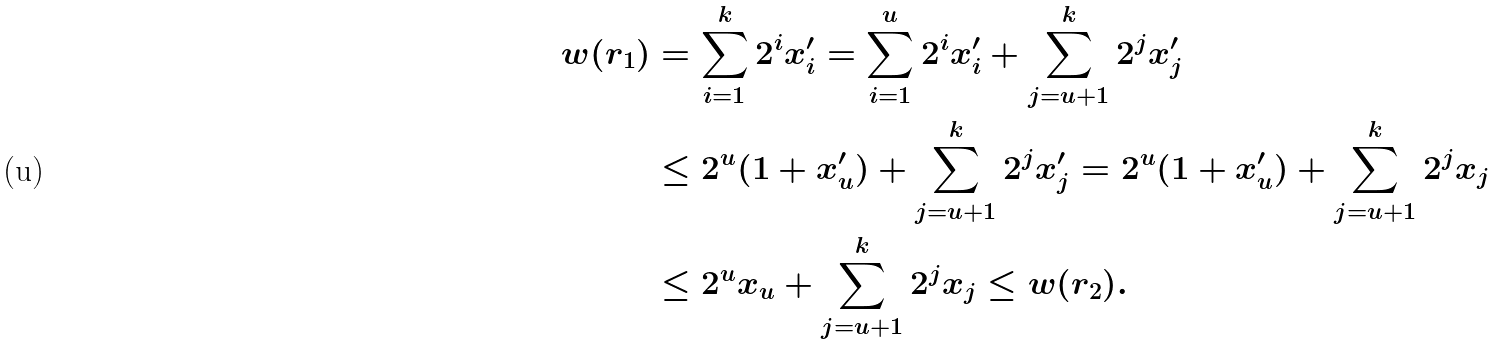Convert formula to latex. <formula><loc_0><loc_0><loc_500><loc_500>w ( r _ { 1 } ) & = \sum _ { i = 1 } ^ { k } 2 ^ { i } x _ { i } ^ { \prime } = \sum _ { i = 1 } ^ { u } 2 ^ { i } x _ { i } ^ { \prime } + \sum _ { j = u + 1 } ^ { k } 2 ^ { j } x _ { j } ^ { \prime } \\ & \leq 2 ^ { u } ( 1 + x _ { u } ^ { \prime } ) + \sum _ { j = u + 1 } ^ { k } 2 ^ { j } x _ { j } ^ { \prime } = 2 ^ { u } ( 1 + x _ { u } ^ { \prime } ) + \sum _ { j = u + 1 } ^ { k } 2 ^ { j } x _ { j } \\ & \leq 2 ^ { u } x _ { u } + \sum _ { j = u + 1 } ^ { k } 2 ^ { j } x _ { j } \leq w ( r _ { 2 } ) .</formula> 